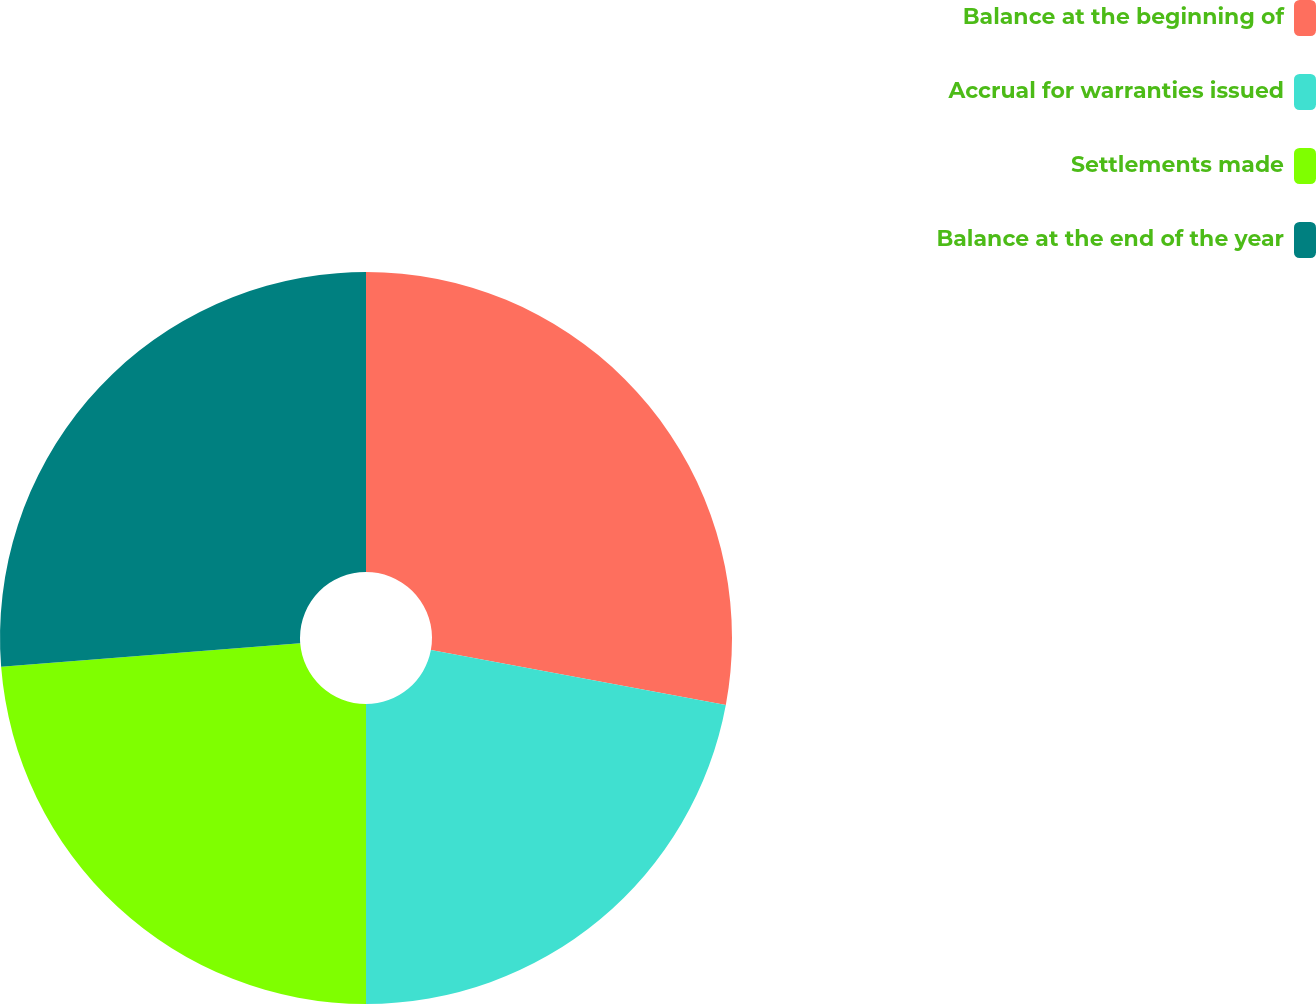<chart> <loc_0><loc_0><loc_500><loc_500><pie_chart><fcel>Balance at the beginning of<fcel>Accrual for warranties issued<fcel>Settlements made<fcel>Balance at the end of the year<nl><fcel>27.93%<fcel>22.07%<fcel>23.75%<fcel>26.25%<nl></chart> 